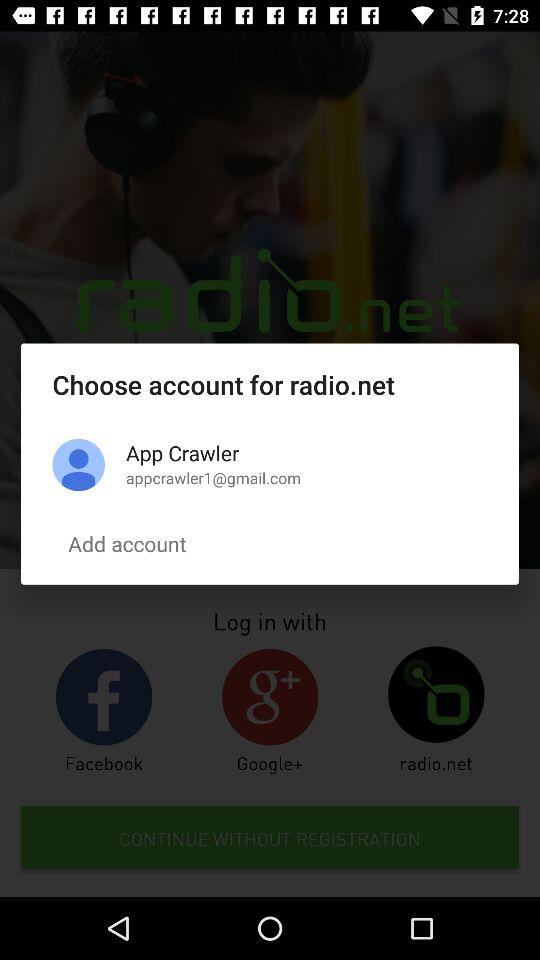How many accounts do I have?
Answer the question using a single word or phrase. 1 